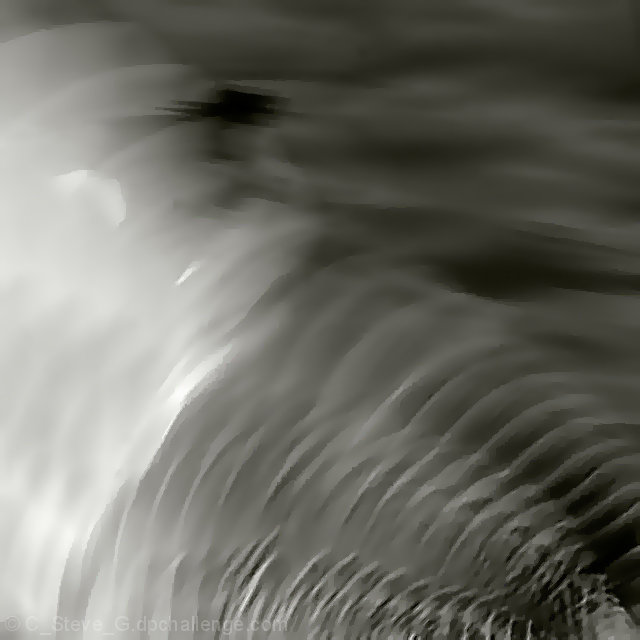Are there any obvious noise artifacts in the image?
A. Yes
B. No
Answer with the option's letter from the given choices directly.
 B. 